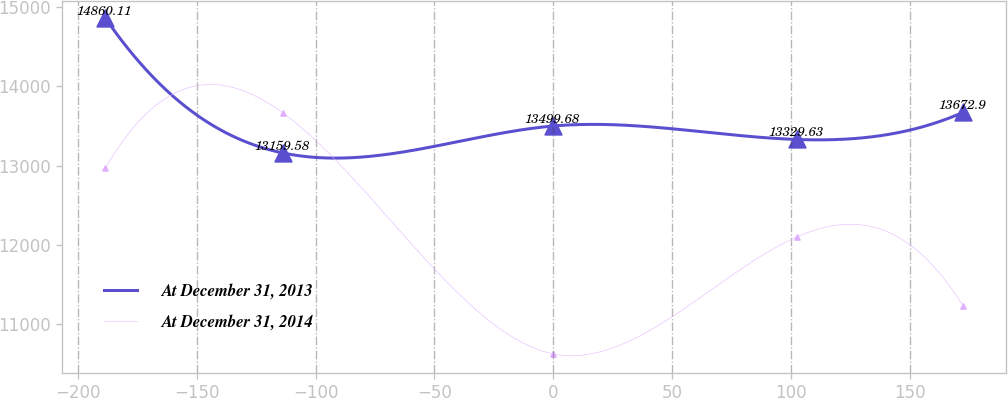<chart> <loc_0><loc_0><loc_500><loc_500><line_chart><ecel><fcel>At December 31, 2013<fcel>At December 31, 2014<nl><fcel>-188.38<fcel>14860.1<fcel>12969.6<nl><fcel>-113.78<fcel>13159.6<fcel>13665.4<nl><fcel>0<fcel>13499.7<fcel>10624.3<nl><fcel>102.3<fcel>13329.6<fcel>12098.9<nl><fcel>172.4<fcel>13672.9<fcel>11223.8<nl></chart> 